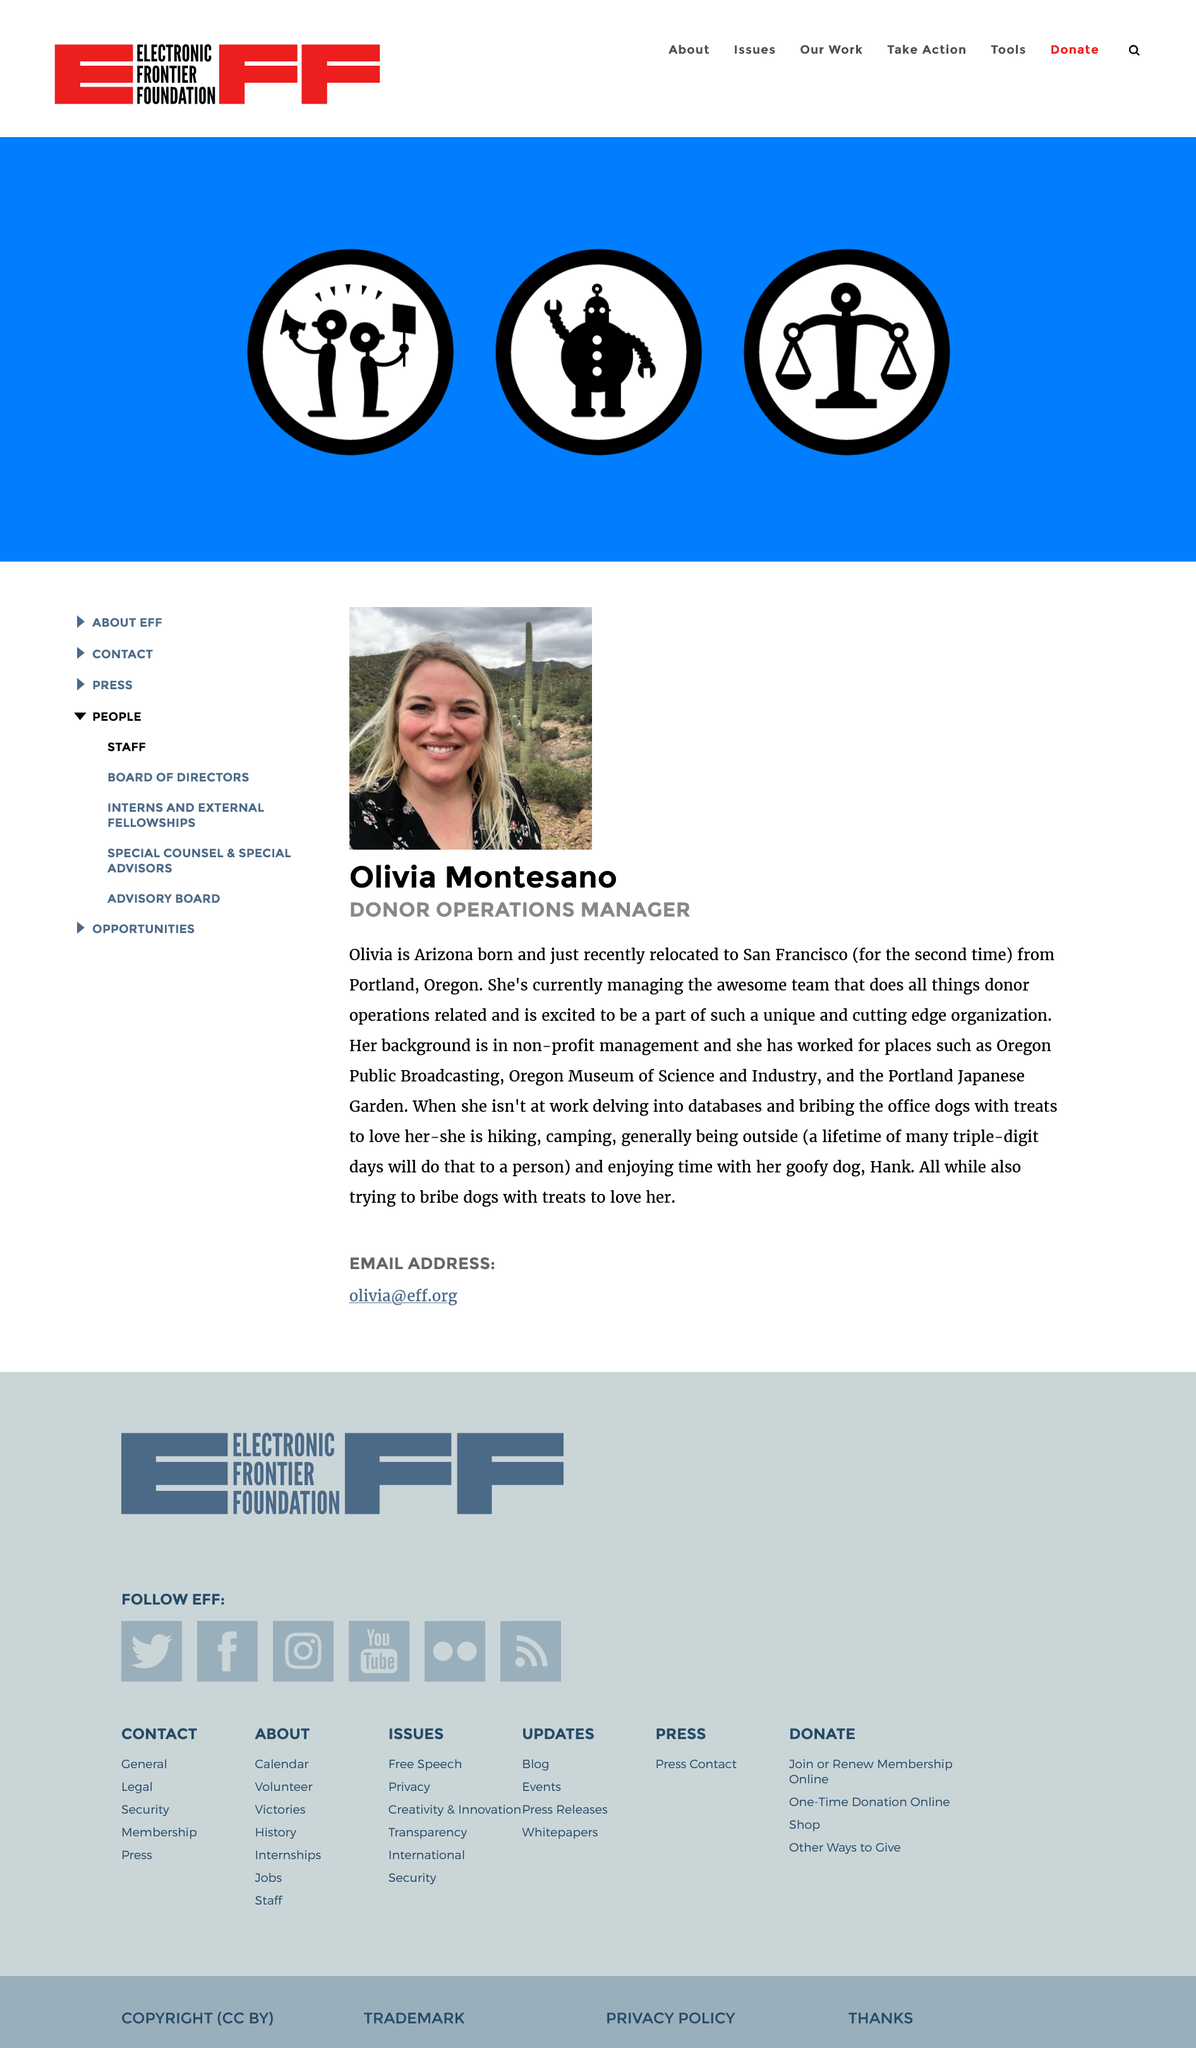Highlight a few significant elements in this photo. Olivia Montesano was born in the state of Arizona. Olivia Montesano has relocated to San Francisco for the second time. 